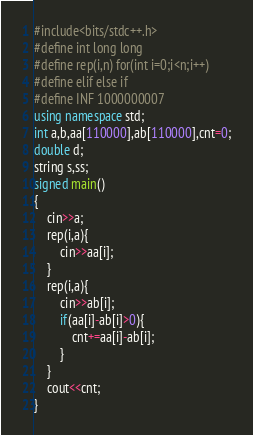<code> <loc_0><loc_0><loc_500><loc_500><_C++_>#include<bits/stdc++.h>
#define int long long
#define rep(i,n) for(int i=0;i<n;i++)
#define elif else if
#define INF 1000000007
using namespace std;
int a,b,aa[110000],ab[110000],cnt=0;
double d;
string s,ss;
signed main()
{
	cin>>a;
	rep(i,a){
		cin>>aa[i];
	}
	rep(i,a){
		cin>>ab[i];
		if(aa[i]-ab[i]>0){
			cnt+=aa[i]-ab[i];
		}
	}
	cout<<cnt;
}</code> 